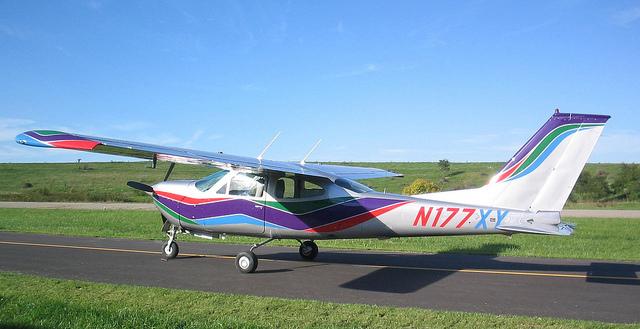Is this a commercial jet plane?
Short answer required. No. Is the plane currently flying?
Keep it brief. No. What letters does this plane have on its side?
Write a very short answer. Nxy. Is the plane secured to the ground?
Write a very short answer. No. 